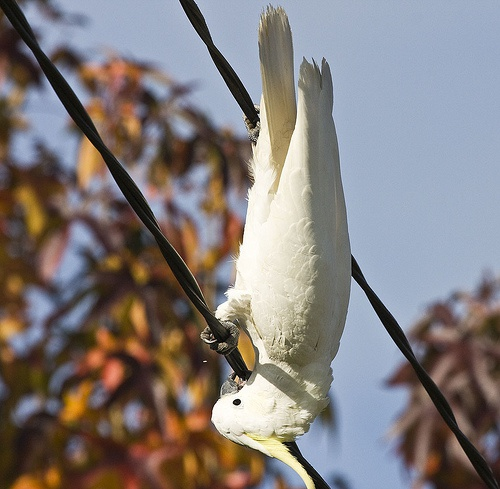Describe the objects in this image and their specific colors. I can see a bird in black, gray, ivory, beige, and tan tones in this image. 